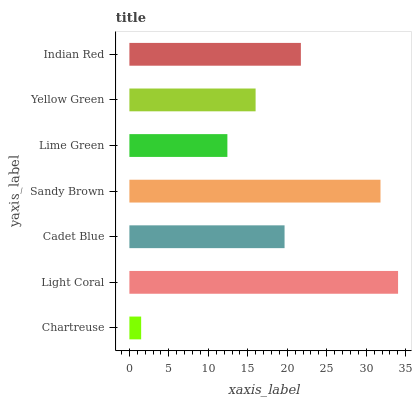Is Chartreuse the minimum?
Answer yes or no. Yes. Is Light Coral the maximum?
Answer yes or no. Yes. Is Cadet Blue the minimum?
Answer yes or no. No. Is Cadet Blue the maximum?
Answer yes or no. No. Is Light Coral greater than Cadet Blue?
Answer yes or no. Yes. Is Cadet Blue less than Light Coral?
Answer yes or no. Yes. Is Cadet Blue greater than Light Coral?
Answer yes or no. No. Is Light Coral less than Cadet Blue?
Answer yes or no. No. Is Cadet Blue the high median?
Answer yes or no. Yes. Is Cadet Blue the low median?
Answer yes or no. Yes. Is Chartreuse the high median?
Answer yes or no. No. Is Lime Green the low median?
Answer yes or no. No. 